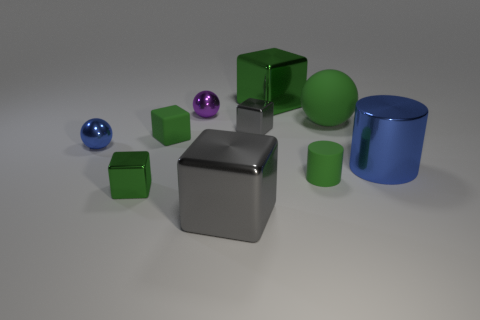How many cylinders are big gray things or big blue things? In the image, there is a total of one cylinder that is big and blue. There are no big gray cylinders visible. 